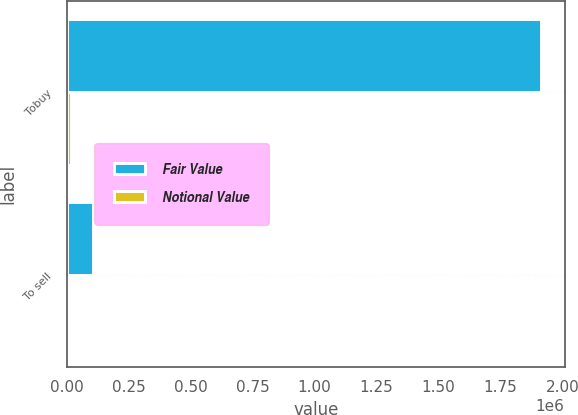Convert chart. <chart><loc_0><loc_0><loc_500><loc_500><stacked_bar_chart><ecel><fcel>Tobuy<fcel>To sell<nl><fcel>Fair Value<fcel>1.91326e+06<fcel>106962<nl><fcel>Notional Value<fcel>17018<fcel>403<nl></chart> 